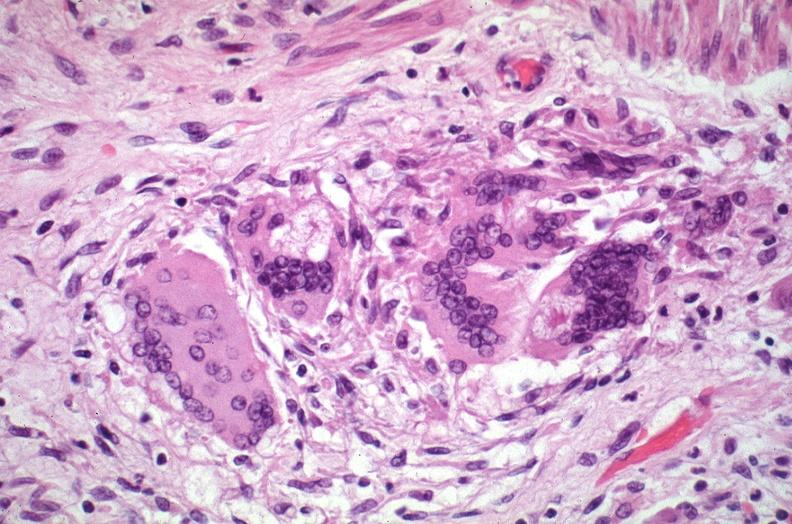s respiratory present?
Answer the question using a single word or phrase. Yes 